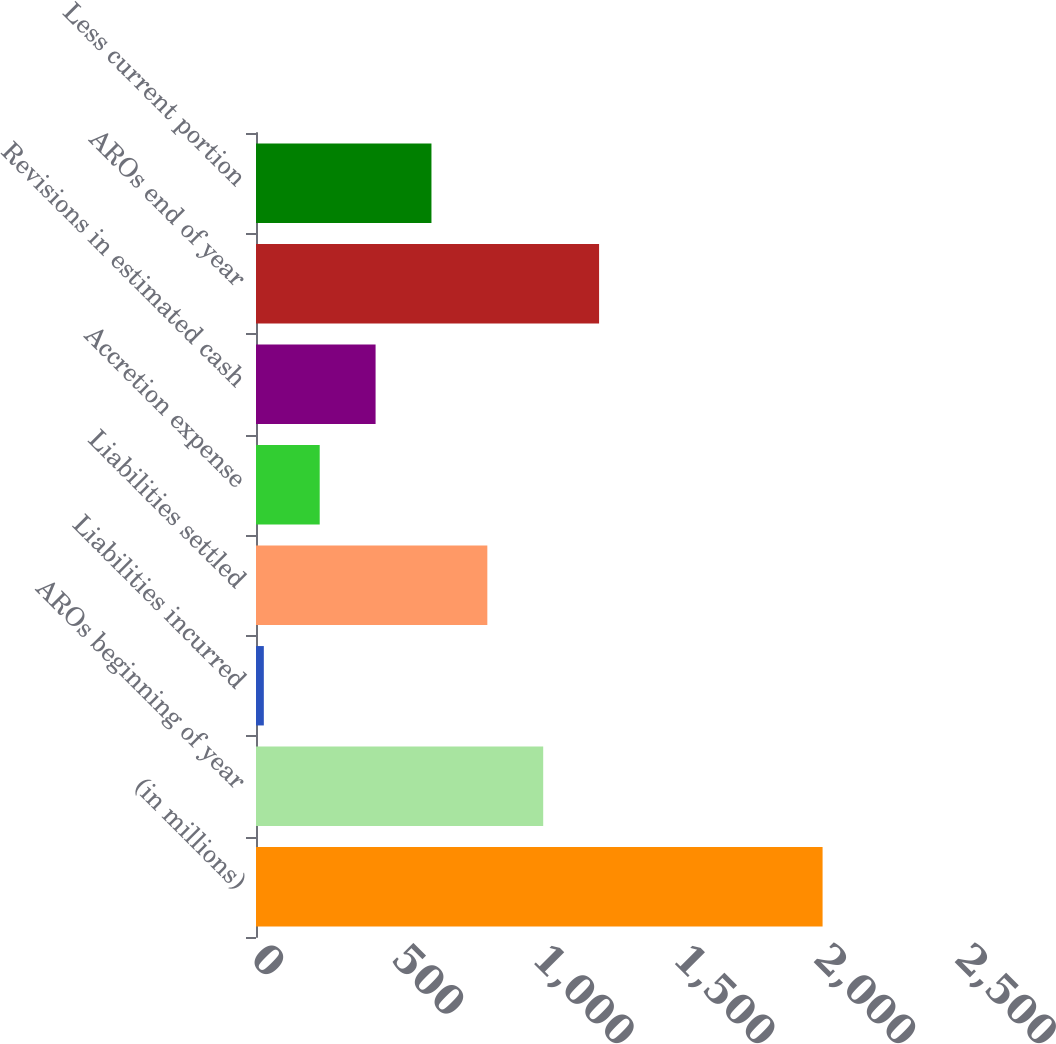<chart> <loc_0><loc_0><loc_500><loc_500><bar_chart><fcel>(in millions)<fcel>AROs beginning of year<fcel>Liabilities incurred<fcel>Liabilities settled<fcel>Accretion expense<fcel>Revisions in estimated cash<fcel>AROs end of year<fcel>Less current portion<nl><fcel>2012<fcel>1019.9<fcel>27.8<fcel>821.48<fcel>226.22<fcel>424.64<fcel>1218.32<fcel>623.06<nl></chart> 